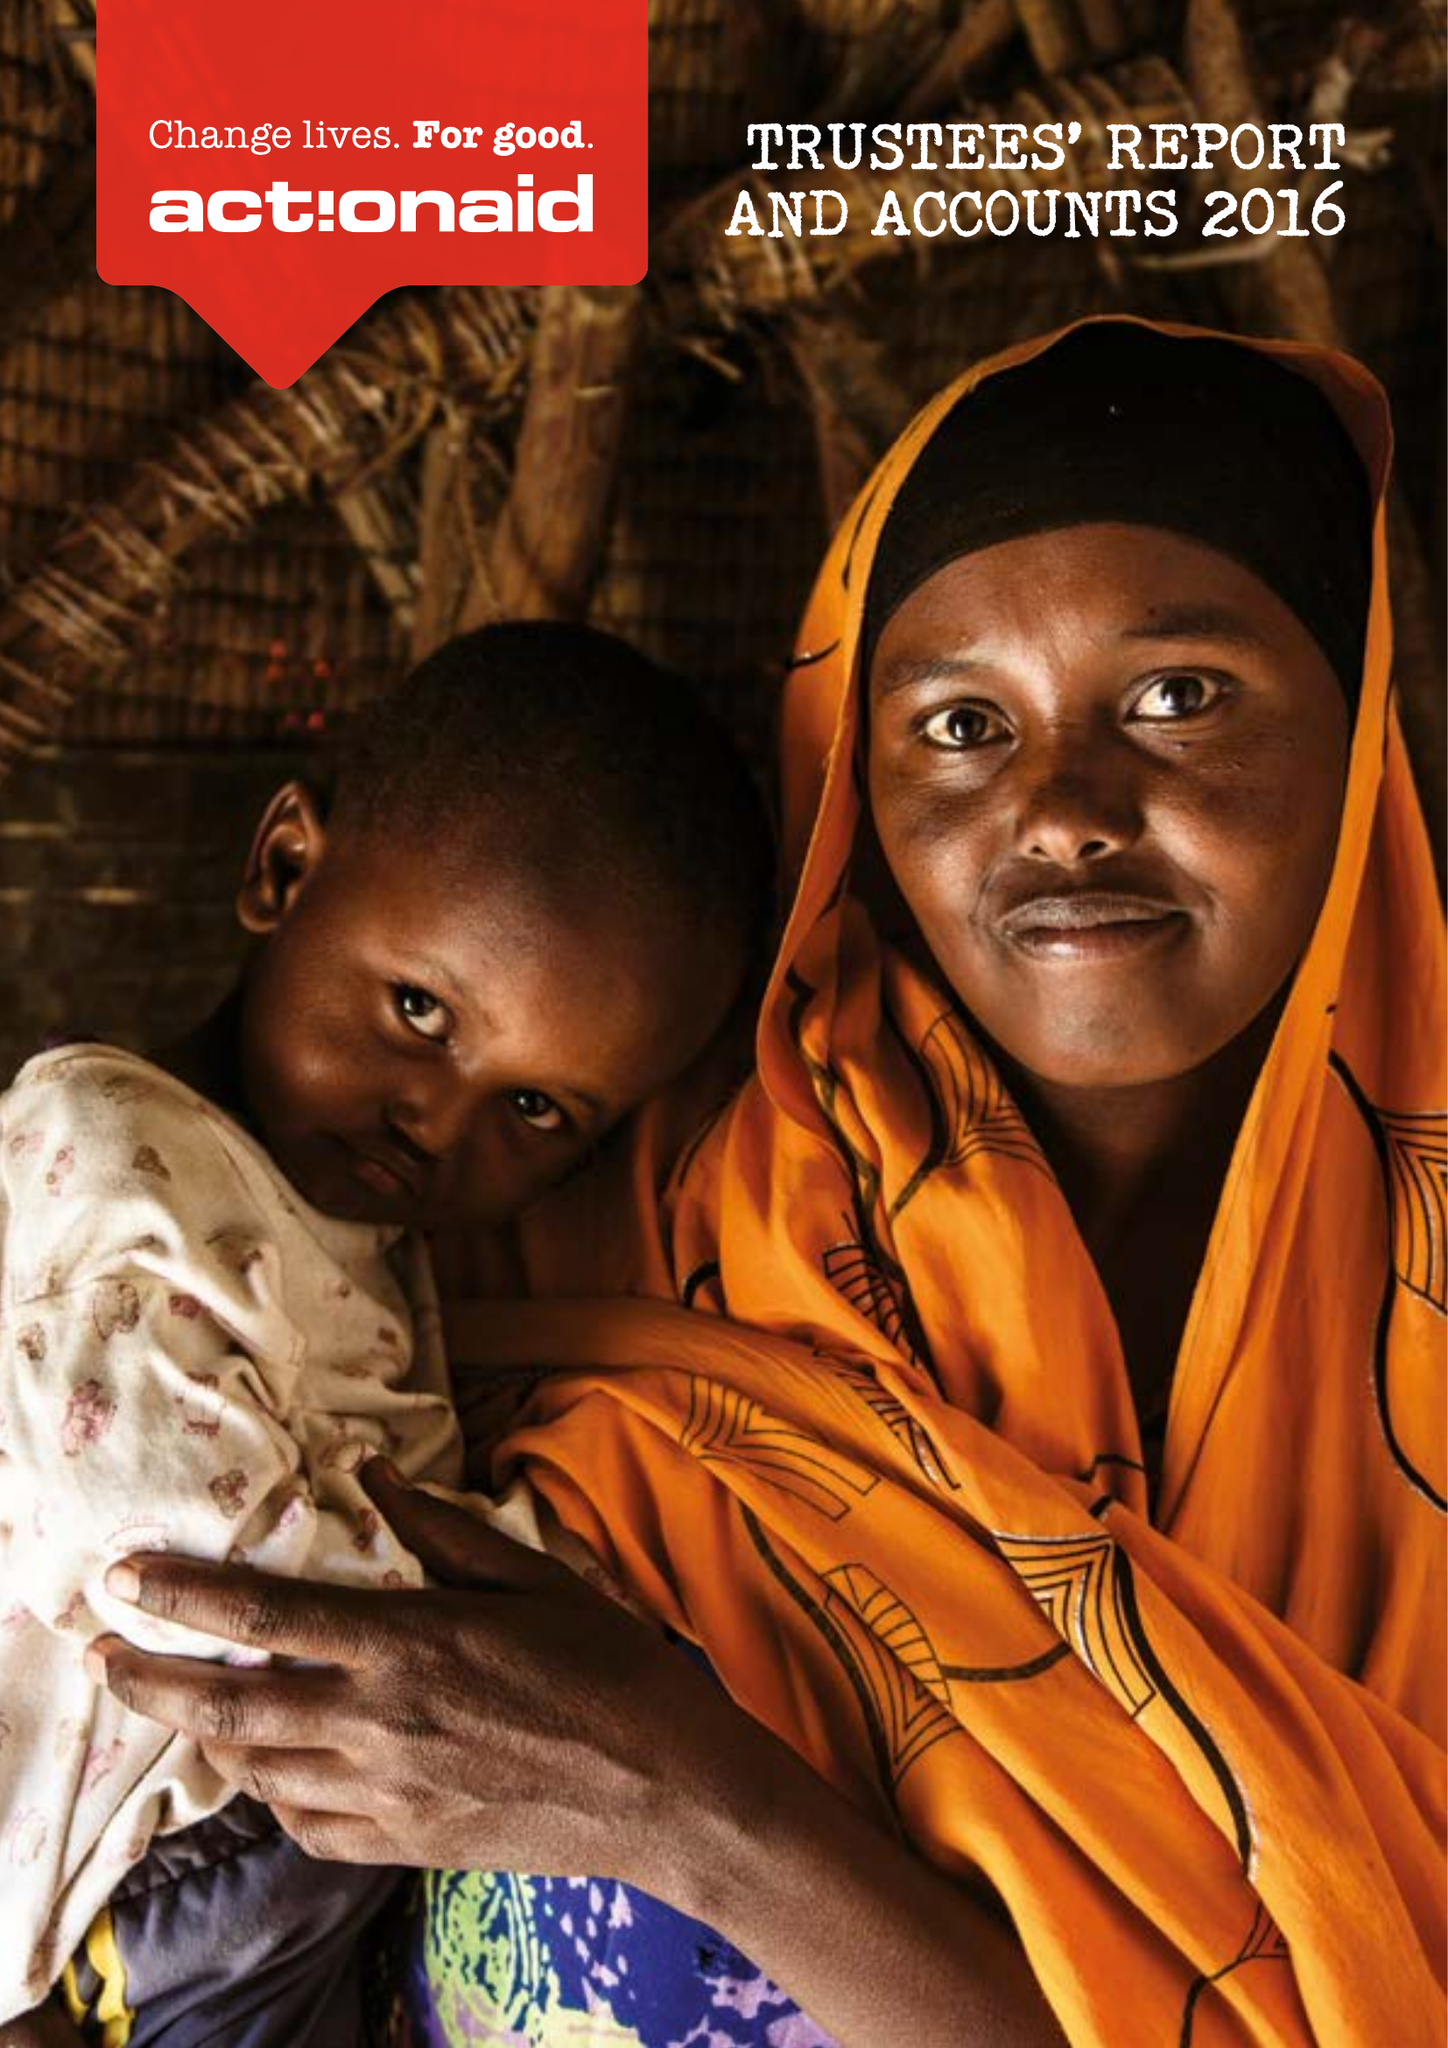What is the value for the charity_number?
Answer the question using a single word or phrase. 274467 